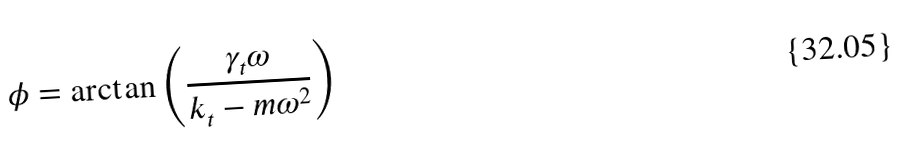Convert formula to latex. <formula><loc_0><loc_0><loc_500><loc_500>\phi = \arctan \left ( \frac { \gamma _ { t } \omega } { k _ { t } - m \omega ^ { 2 } } \right )</formula> 